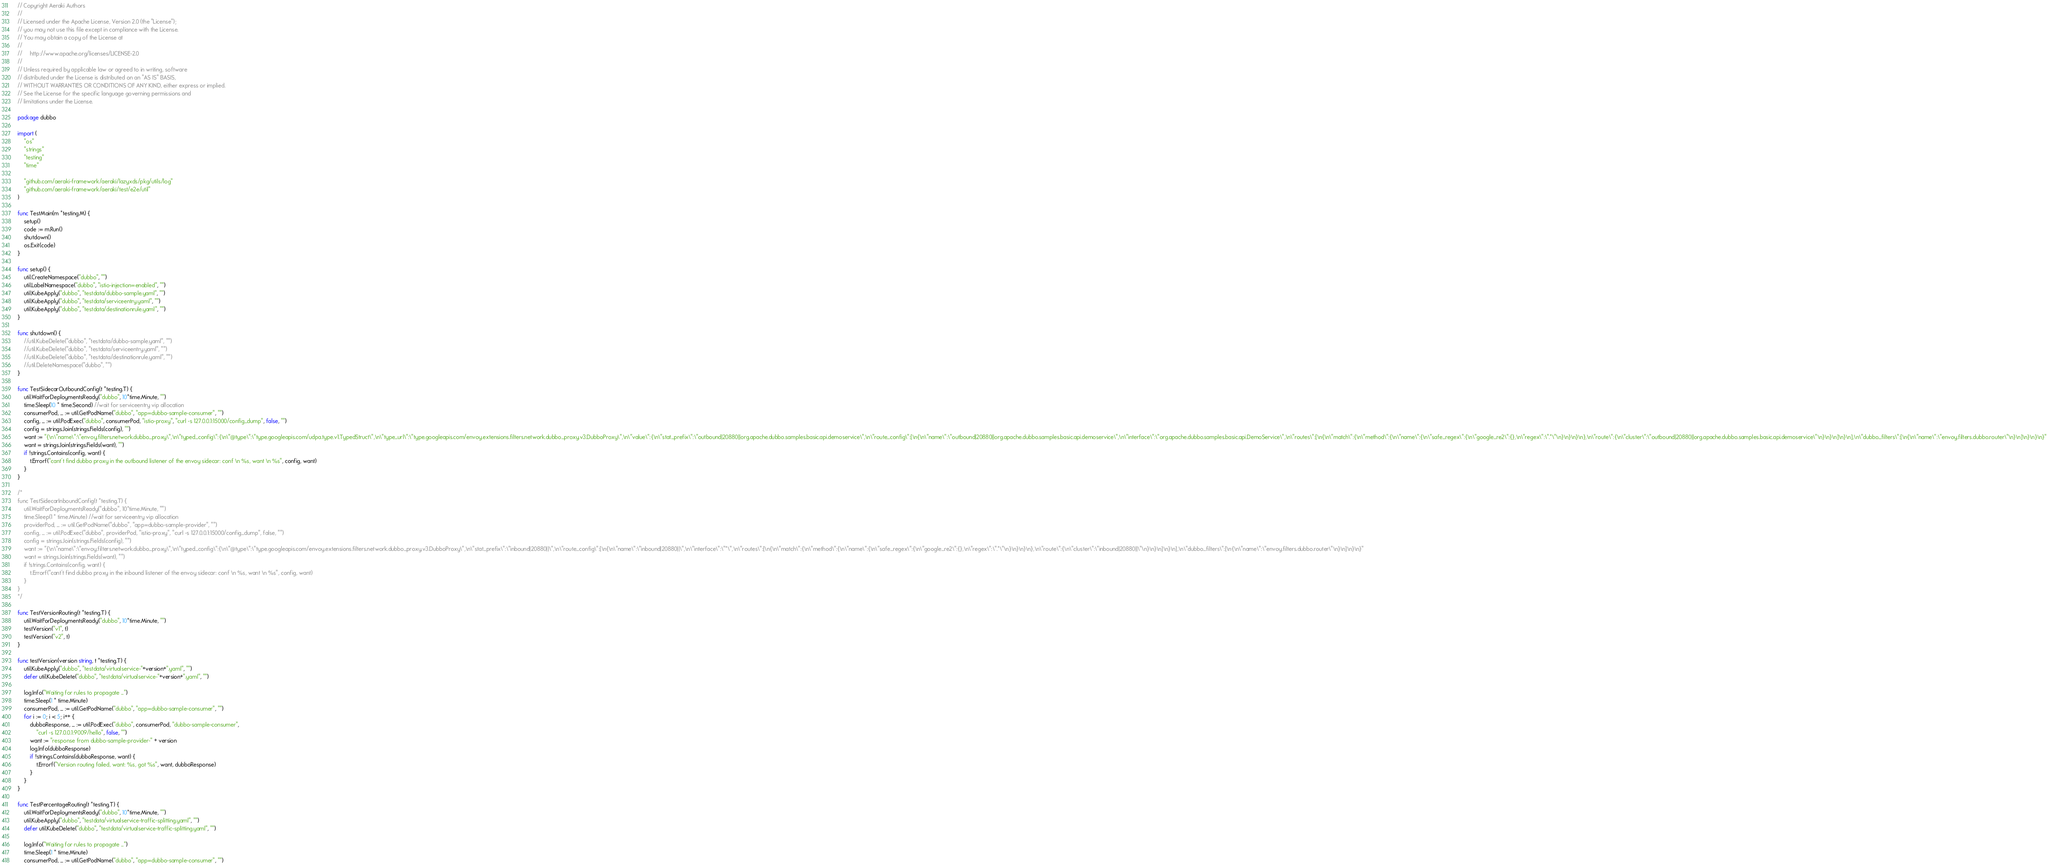Convert code to text. <code><loc_0><loc_0><loc_500><loc_500><_Go_>// Copyright Aeraki Authors
//
// Licensed under the Apache License, Version 2.0 (the "License");
// you may not use this file except in compliance with the License.
// You may obtain a copy of the License at
//
//     http://www.apache.org/licenses/LICENSE-2.0
//
// Unless required by applicable law or agreed to in writing, software
// distributed under the License is distributed on an "AS IS" BASIS,
// WITHOUT WARRANTIES OR CONDITIONS OF ANY KIND, either express or implied.
// See the License for the specific language governing permissions and
// limitations under the License.

package dubbo

import (
	"os"
	"strings"
	"testing"
	"time"

	"github.com/aeraki-framework/aeraki/lazyxds/pkg/utils/log"
	"github.com/aeraki-framework/aeraki/test/e2e/util"
)

func TestMain(m *testing.M) {
	setup()
	code := m.Run()
	shutdown()
	os.Exit(code)
}

func setup() {
	util.CreateNamespace("dubbo", "")
	util.LabelNamespace("dubbo", "istio-injection=enabled", "")
	util.KubeApply("dubbo", "testdata/dubbo-sample.yaml", "")
	util.KubeApply("dubbo", "testdata/serviceentry.yaml", "")
	util.KubeApply("dubbo", "testdata/destinationrule.yaml", "")
}

func shutdown() {
	//util.KubeDelete("dubbo", "testdata/dubbo-sample.yaml", "")
	//util.KubeDelete("dubbo", "testdata/serviceentry.yaml", "")
	//util.KubeDelete("dubbo", "testdata/destinationrule.yaml", "")
	//util.DeleteNamespace("dubbo", "")
}

func TestSidecarOutboundConfig(t *testing.T) {
	util.WaitForDeploymentsReady("dubbo", 10*time.Minute, "")
	time.Sleep(10 * time.Second) //wait for serviceentry vip allocation
	consumerPod, _ := util.GetPodName("dubbo", "app=dubbo-sample-consumer", "")
	config, _ := util.PodExec("dubbo", consumerPod, "istio-proxy", "curl -s 127.0.0.1:15000/config_dump", false, "")
	config = strings.Join(strings.Fields(config), "")
	want := "{\n\"name\":\"envoy.filters.network.dubbo_proxy\",\n\"typed_config\":{\n\"@type\":\"type.googleapis.com/udpa.type.v1.TypedStruct\",\n\"type_url\":\"type.googleapis.com/envoy.extensions.filters.network.dubbo_proxy.v3.DubboProxy\",\n\"value\":{\n\"stat_prefix\":\"outbound|20880||org.apache.dubbo.samples.basic.api.demoservice\",\n\"route_config\":[\n{\n\"name\":\"outbound|20880||org.apache.dubbo.samples.basic.api.demoservice\",\n\"interface\":\"org.apache.dubbo.samples.basic.api.DemoService\",\n\"routes\":[\n{\n\"match\":{\n\"method\":{\n\"name\":{\n\"safe_regex\":{\n\"google_re2\":{},\n\"regex\":\".*\"\n}\n}\n}\n},\n\"route\":{\n\"cluster\":\"outbound|20880||org.apache.dubbo.samples.basic.api.demoservice\"\n}\n}\n]\n}\n],\n\"dubbo_filters\":[\n{\n\"name\":\"envoy.filters.dubbo.router\"\n}\n]\n}\n}\n}"
	want = strings.Join(strings.Fields(want), "")
	if !strings.Contains(config, want) {
		t.Errorf("cant't find dubbo proxy in the outbound listener of the envoy sidecar: conf \n %s, want \n %s", config, want)
	}
}

/*
func TestSidecarInboundConfig(t *testing.T) {
	util.WaitForDeploymentsReady("dubbo", 10*time.Minute, "")
	time.Sleep(1 * time.Minute) //wait for serviceentry vip allocation
	providerPod, _ := util.GetPodName("dubbo", "app=dubbo-sample-provider", "")
	config, _ := util.PodExec("dubbo", providerPod, "istio-proxy", "curl -s 127.0.0.1:15000/config_dump", false, "")
	config = strings.Join(strings.Fields(config), "")
	want := "{\n\"name\":\"envoy.filters.network.dubbo_proxy\",\n\"typed_config\":{\n\"@type\":\"type.googleapis.com/envoy.extensions.filters.network.dubbo_proxy.v3.DubboProxy\",\n\"stat_prefix\":\"inbound|20880||\",\n\"route_config\":[\n{\n\"name\":\"inbound|20880||\",\n\"interface\":\"*\",\n\"routes\":[\n{\n\"match\":{\n\"method\":{\n\"name\":{\n\"safe_regex\":{\n\"google_re2\":{},\n\"regex\":\".*\"\n}\n}\n}\n},\n\"route\":{\n\"cluster\":\"inbound|20880||\"\n}\n}\n]\n}\n],\n\"dubbo_filters\":[\n{\n\"name\":\"envoy.filters.dubbo.router\"\n}\n]\n}\n}"
	want = strings.Join(strings.Fields(want), "")
	if !strings.Contains(config, want) {
		t.Errorf("cant't find dubbo proxy in the inbound listener of the envoy sidecar: conf \n %s, want \n %s", config, want)
	}
}
*/

func TestVersionRouting(t *testing.T) {
	util.WaitForDeploymentsReady("dubbo", 10*time.Minute, "")
	testVersion("v1", t)
	testVersion("v2", t)
}

func testVersion(version string, t *testing.T) {
	util.KubeApply("dubbo", "testdata/virtualservice-"+version+".yaml", "")
	defer util.KubeDelete("dubbo", "testdata/virtualservice-"+version+".yaml", "")

	log.Info("Waiting for rules to propagate ...")
	time.Sleep(1 * time.Minute)
	consumerPod, _ := util.GetPodName("dubbo", "app=dubbo-sample-consumer", "")
	for i := 0; i < 5; i++ {
		dubboResponse, _ := util.PodExec("dubbo", consumerPod, "dubbo-sample-consumer",
			"curl -s 127.0.0.1:9009/hello", false, "")
		want := "response from dubbo-sample-provider-" + version
		log.Info(dubboResponse)
		if !strings.Contains(dubboResponse, want) {
			t.Errorf("Version routing failed, want: %s, got %s", want, dubboResponse)
		}
	}
}

func TestPercentageRouting(t *testing.T) {
	util.WaitForDeploymentsReady("dubbo", 10*time.Minute, "")
	util.KubeApply("dubbo", "testdata/virtualservice-traffic-splitting.yaml", "")
	defer util.KubeDelete("dubbo", "testdata/virtualservice-traffic-splitting.yaml", "")

	log.Info("Waiting for rules to propagate ...")
	time.Sleep(1 * time.Minute)
	consumerPod, _ := util.GetPodName("dubbo", "app=dubbo-sample-consumer", "")</code> 